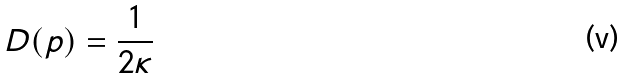<formula> <loc_0><loc_0><loc_500><loc_500>D ( p ) = \frac { 1 } { 2 \kappa }</formula> 